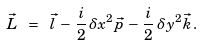Convert formula to latex. <formula><loc_0><loc_0><loc_500><loc_500>\vec { L } \ = \ \vec { l } \, - \, \frac { i } { 2 } \, \delta x ^ { 2 } \vec { p } \, - \, \frac { i } { 2 } \, \delta y ^ { 2 } \vec { k } \, .</formula> 